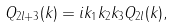<formula> <loc_0><loc_0><loc_500><loc_500>Q _ { 2 l + 3 } ( k ) = i k _ { 1 } k _ { 2 } k _ { 3 } Q _ { 2 l } ( k ) ,</formula> 